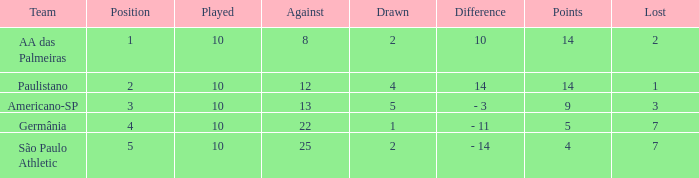What is the sum of Against when the lost is more than 7? None. 